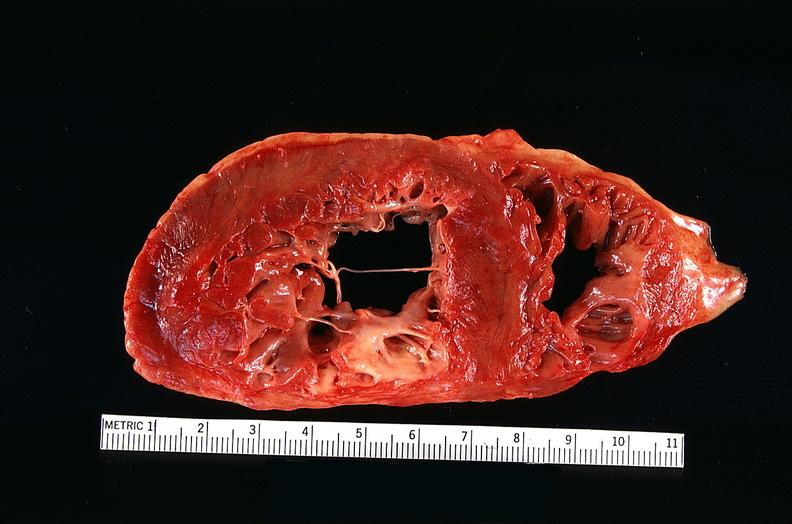where is this?
Answer the question using a single word or phrase. Heart 